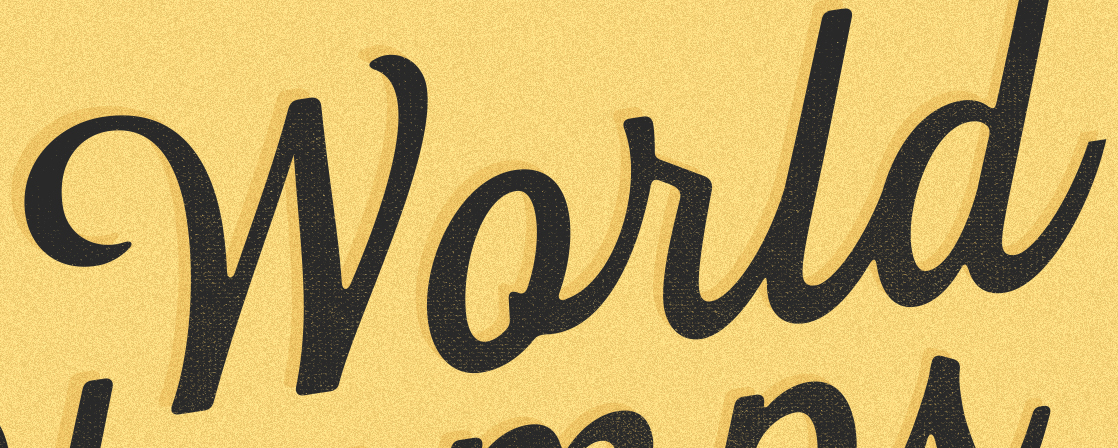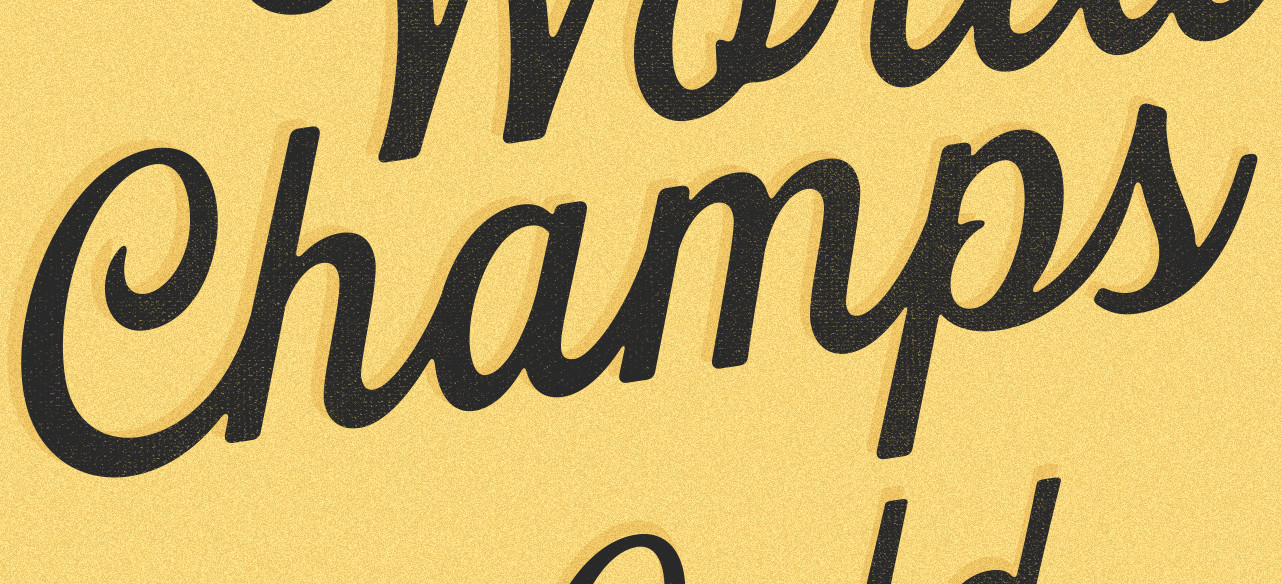Transcribe the words shown in these images in order, separated by a semicolon. World; Champs 